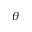<formula> <loc_0><loc_0><loc_500><loc_500>\theta</formula> 